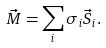Convert formula to latex. <formula><loc_0><loc_0><loc_500><loc_500>\vec { M } = \sum _ { i } \sigma _ { i } \vec { S } _ { i } .</formula> 